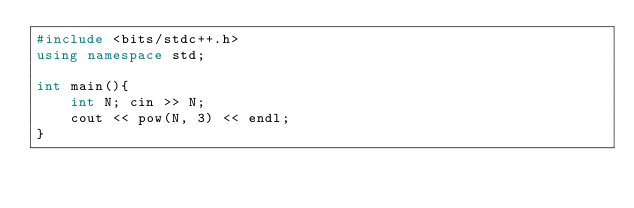Convert code to text. <code><loc_0><loc_0><loc_500><loc_500><_C++_>#include <bits/stdc++.h>
using namespace std;

int main(){
    int N; cin >> N;
    cout << pow(N, 3) << endl;
}</code> 